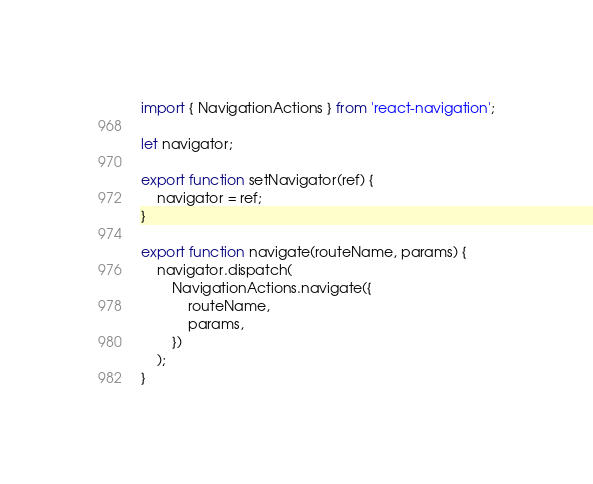Convert code to text. <code><loc_0><loc_0><loc_500><loc_500><_JavaScript_>import { NavigationActions } from 'react-navigation';

let navigator;

export function setNavigator(ref) {
	navigator = ref;
}

export function navigate(routeName, params) {
	navigator.dispatch(
		NavigationActions.navigate({
			routeName,
			params,
		})
	);
}
</code> 